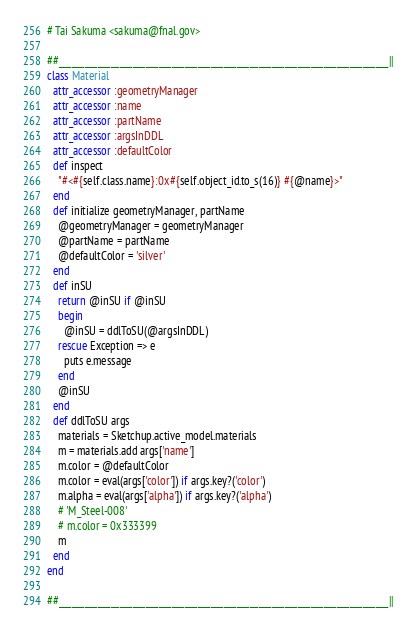<code> <loc_0><loc_0><loc_500><loc_500><_Ruby_># Tai Sakuma <sakuma@fnal.gov>

##____________________________________________________________________________||
class Material
  attr_accessor :geometryManager
  attr_accessor :name
  attr_accessor :partName
  attr_accessor :argsInDDL
  attr_accessor :defaultColor
  def inspect
    "#<#{self.class.name}:0x#{self.object_id.to_s(16)} #{@name}>"
  end
  def initialize geometryManager, partName
    @geometryManager = geometryManager
    @partName = partName
    @defaultColor = 'silver'
  end
  def inSU
    return @inSU if @inSU
    begin
      @inSU = ddlToSU(@argsInDDL)
    rescue Exception => e
      puts e.message
    end
    @inSU
  end
  def ddlToSU args
    materials = Sketchup.active_model.materials
    m = materials.add args['name']
    m.color = @defaultColor
    m.color = eval(args['color']) if args.key?('color')
    m.alpha = eval(args['alpha']) if args.key?('alpha')
    # 'M_Steel-008'
    # m.color = 0x333399
    m
  end
end

##____________________________________________________________________________||
</code> 